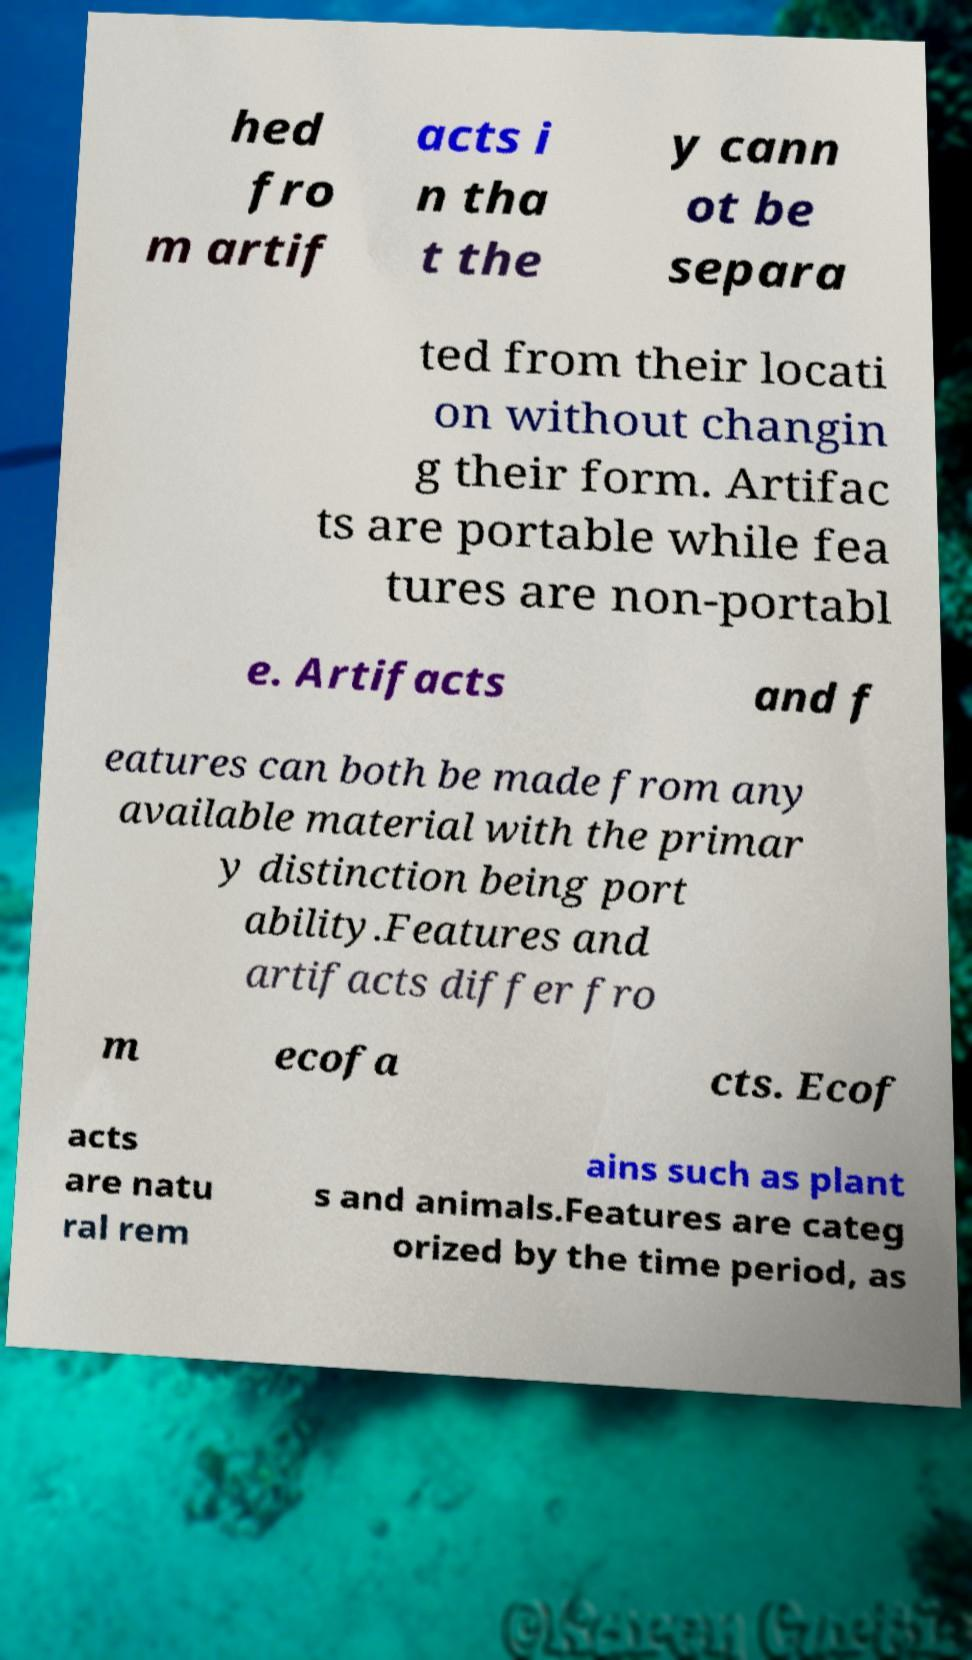Please identify and transcribe the text found in this image. hed fro m artif acts i n tha t the y cann ot be separa ted from their locati on without changin g their form. Artifac ts are portable while fea tures are non-portabl e. Artifacts and f eatures can both be made from any available material with the primar y distinction being port ability.Features and artifacts differ fro m ecofa cts. Ecof acts are natu ral rem ains such as plant s and animals.Features are categ orized by the time period, as 